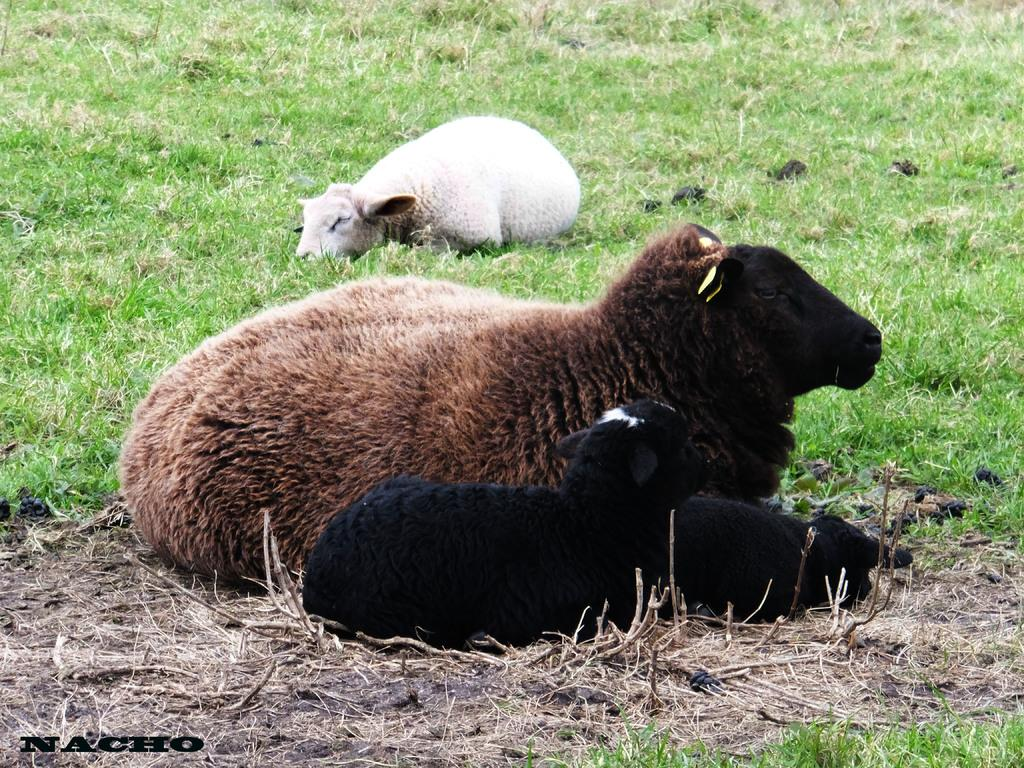How many adult sheep are in the image? There are two adult sheep in the image. How many baby sheep are in the image? There are two baby sheep in the image. What is the sheep laying on in the image? The sheep are laying on the grass. What type of lettuce is growing near the sheep in the image? There is no lettuce present in the image; the sheep are laying on the grass. Can you see any feathers on the sheep in the image? Sheep do not have feathers; they have wool. In the image, the sheep are laying on the grass, and there is no mention of feathers. 